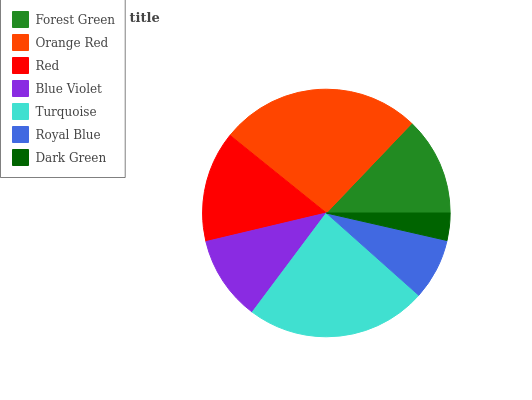Is Dark Green the minimum?
Answer yes or no. Yes. Is Orange Red the maximum?
Answer yes or no. Yes. Is Red the minimum?
Answer yes or no. No. Is Red the maximum?
Answer yes or no. No. Is Orange Red greater than Red?
Answer yes or no. Yes. Is Red less than Orange Red?
Answer yes or no. Yes. Is Red greater than Orange Red?
Answer yes or no. No. Is Orange Red less than Red?
Answer yes or no. No. Is Forest Green the high median?
Answer yes or no. Yes. Is Forest Green the low median?
Answer yes or no. Yes. Is Turquoise the high median?
Answer yes or no. No. Is Blue Violet the low median?
Answer yes or no. No. 